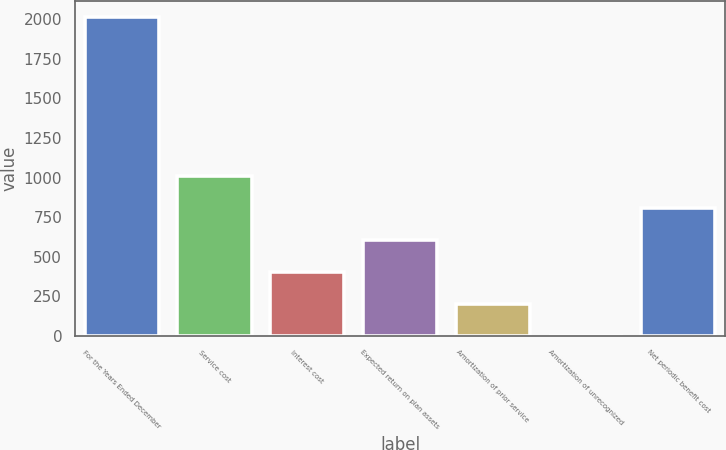Convert chart to OTSL. <chart><loc_0><loc_0><loc_500><loc_500><bar_chart><fcel>For the Years Ended December<fcel>Service cost<fcel>Interest cost<fcel>Expected return on plan assets<fcel>Amortization of prior service<fcel>Amortization of unrecognized<fcel>Net periodic benefit cost<nl><fcel>2014<fcel>1007.25<fcel>403.2<fcel>604.55<fcel>201.85<fcel>0.5<fcel>805.9<nl></chart> 